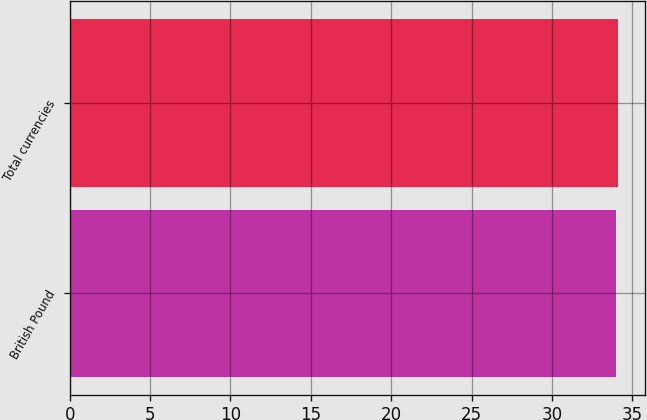<chart> <loc_0><loc_0><loc_500><loc_500><bar_chart><fcel>British Pound<fcel>Total currencies<nl><fcel>34<fcel>34.1<nl></chart> 